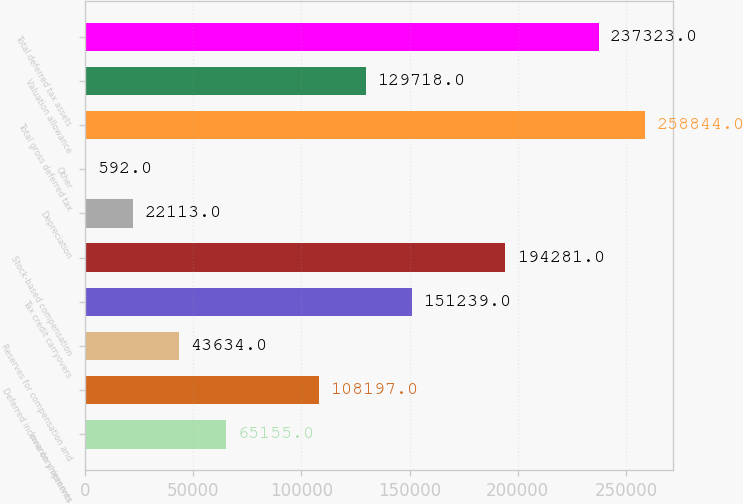Convert chart. <chart><loc_0><loc_0><loc_500><loc_500><bar_chart><fcel>Inventory reserves<fcel>Deferred income on shipments<fcel>Reserves for compensation and<fcel>Tax credit carryovers<fcel>Stock-based compensation<fcel>Depreciation<fcel>Other<fcel>Total gross deferred tax<fcel>Valuation allowance<fcel>Total deferred tax assets<nl><fcel>65155<fcel>108197<fcel>43634<fcel>151239<fcel>194281<fcel>22113<fcel>592<fcel>258844<fcel>129718<fcel>237323<nl></chart> 